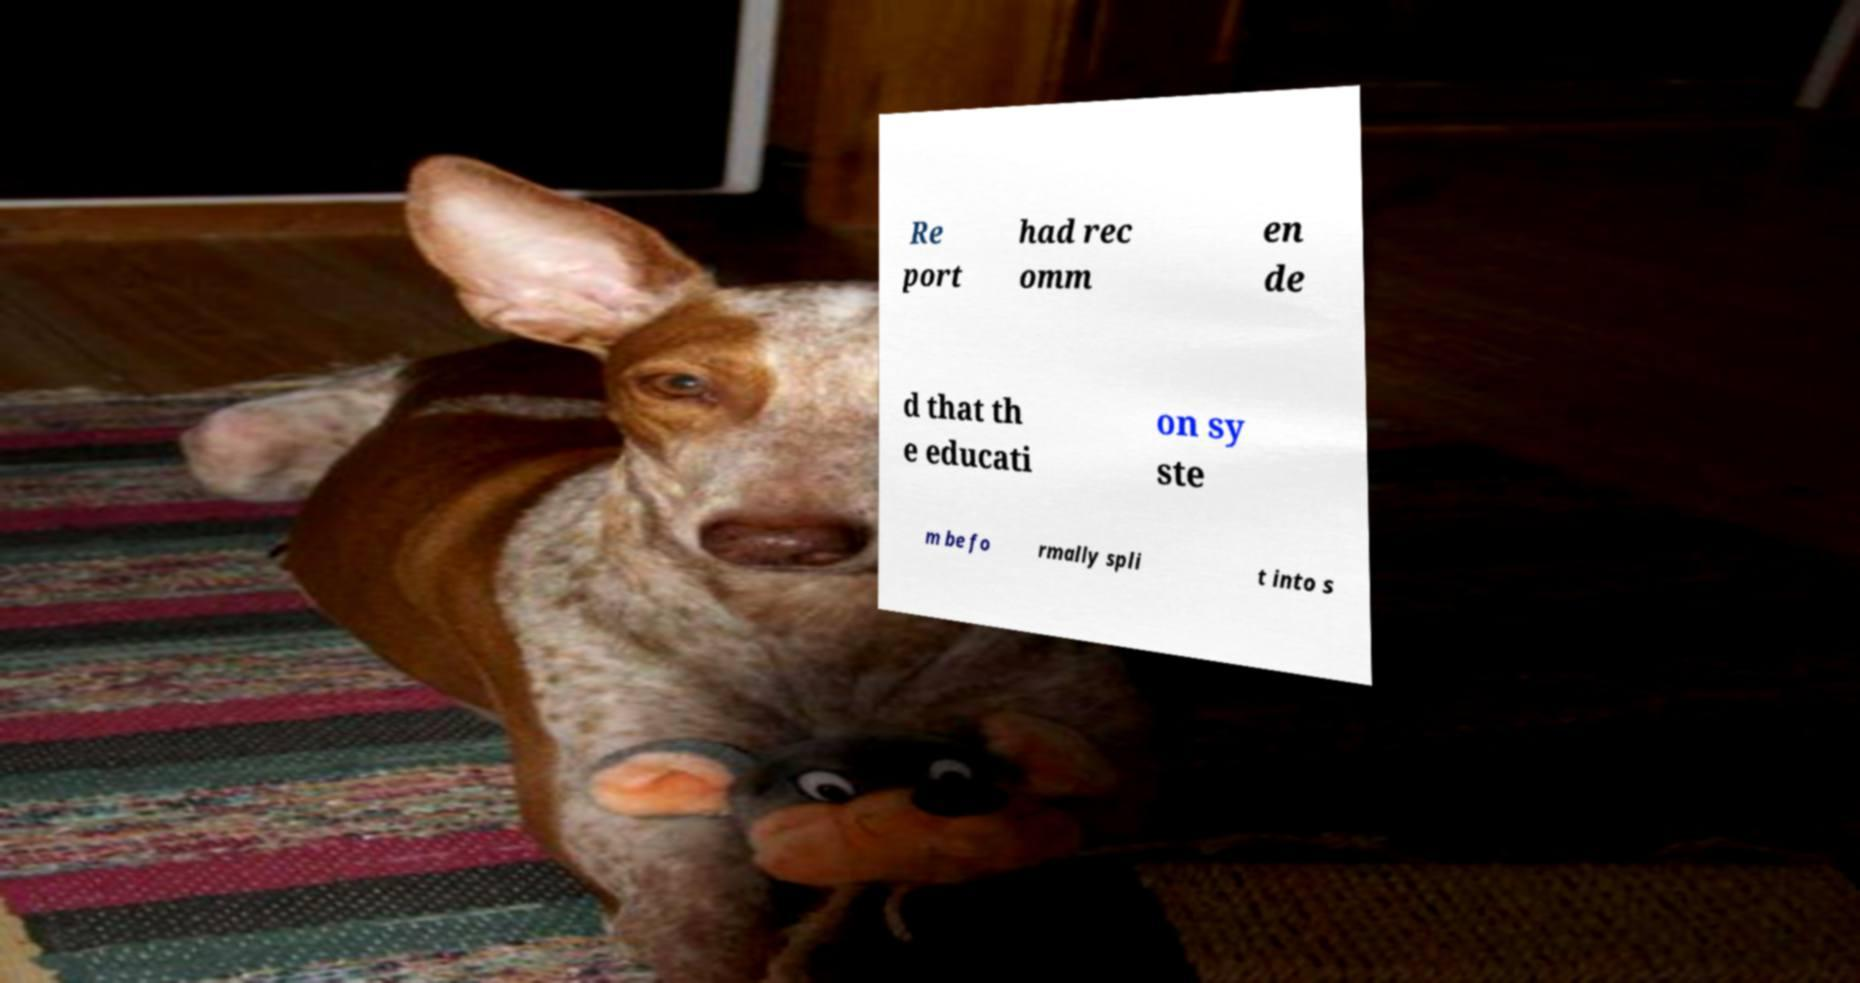Please read and relay the text visible in this image. What does it say? Re port had rec omm en de d that th e educati on sy ste m be fo rmally spli t into s 